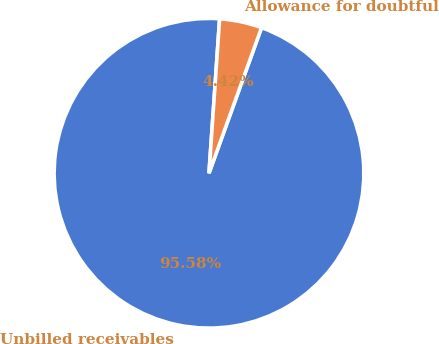Convert chart. <chart><loc_0><loc_0><loc_500><loc_500><pie_chart><fcel>Unbilled receivables<fcel>Allowance for doubtful<nl><fcel>95.58%<fcel>4.42%<nl></chart> 